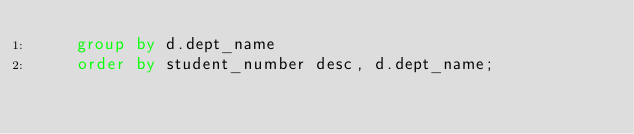Convert code to text. <code><loc_0><loc_0><loc_500><loc_500><_SQL_>    group by d.dept_name
    order by student_number desc, d.dept_name;</code> 